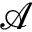Convert formula to latex. <formula><loc_0><loc_0><loc_500><loc_500>\mathcal { A }</formula> 